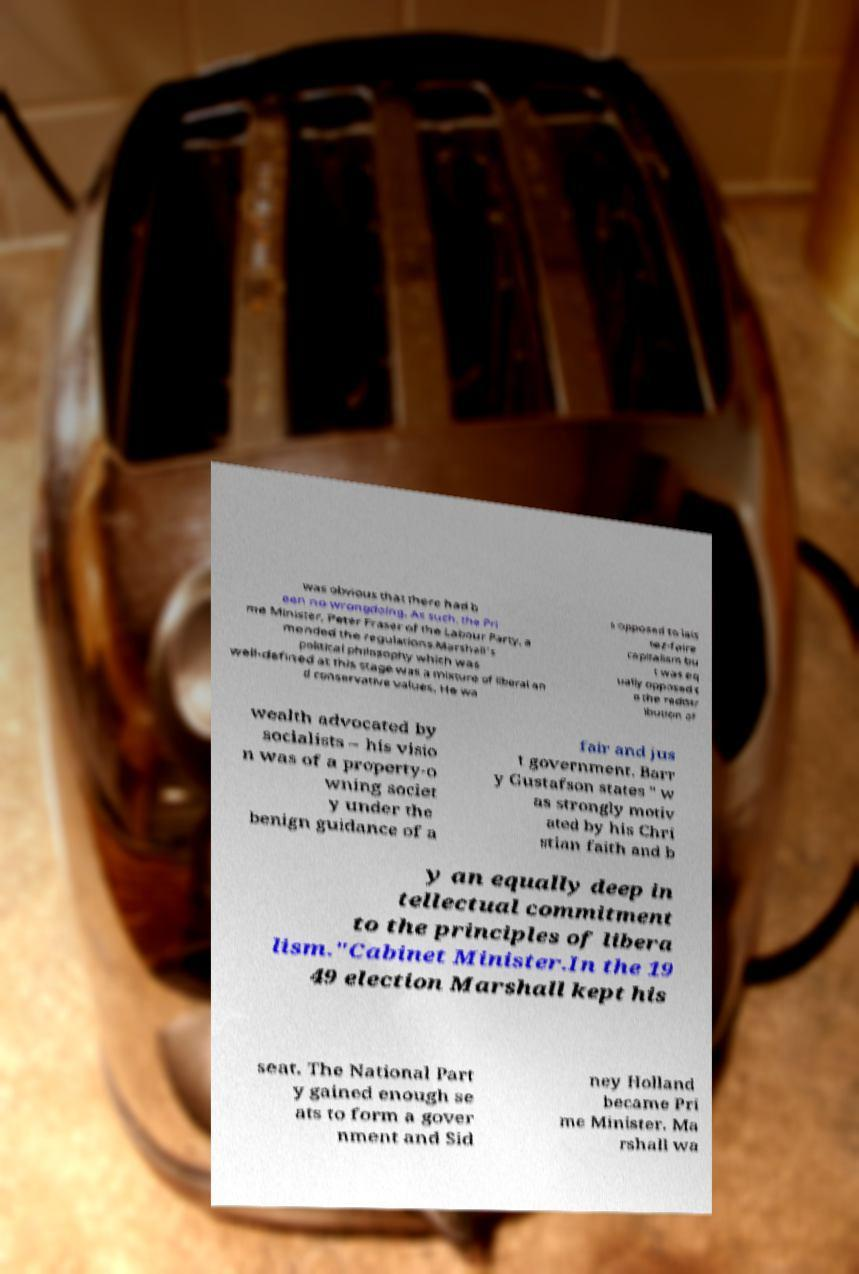I need the written content from this picture converted into text. Can you do that? was obvious that there had b een no wrongdoing. As such, the Pri me Minister, Peter Fraser of the Labour Party, a mended the regulations.Marshall's political philosophy which was well-defined at this stage was a mixture of liberal an d conservative values. He wa s opposed to lais sez-faire capitalism bu t was eq ually opposed t o the redistr ibution of wealth advocated by socialists – his visio n was of a property-o wning societ y under the benign guidance of a fair and jus t government. Barr y Gustafson states " w as strongly motiv ated by his Chri stian faith and b y an equally deep in tellectual commitment to the principles of libera lism."Cabinet Minister.In the 19 49 election Marshall kept his seat. The National Part y gained enough se ats to form a gover nment and Sid ney Holland became Pri me Minister. Ma rshall wa 